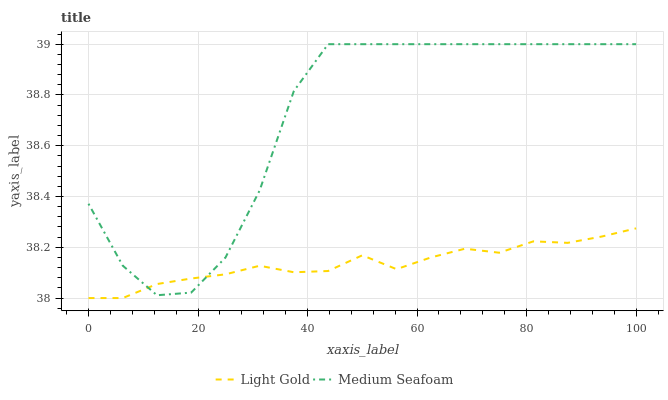Does Light Gold have the minimum area under the curve?
Answer yes or no. Yes. Does Medium Seafoam have the maximum area under the curve?
Answer yes or no. Yes. Does Medium Seafoam have the minimum area under the curve?
Answer yes or no. No. Is Light Gold the smoothest?
Answer yes or no. Yes. Is Medium Seafoam the roughest?
Answer yes or no. Yes. Is Medium Seafoam the smoothest?
Answer yes or no. No. Does Light Gold have the lowest value?
Answer yes or no. Yes. Does Medium Seafoam have the lowest value?
Answer yes or no. No. Does Medium Seafoam have the highest value?
Answer yes or no. Yes. Does Light Gold intersect Medium Seafoam?
Answer yes or no. Yes. Is Light Gold less than Medium Seafoam?
Answer yes or no. No. Is Light Gold greater than Medium Seafoam?
Answer yes or no. No. 